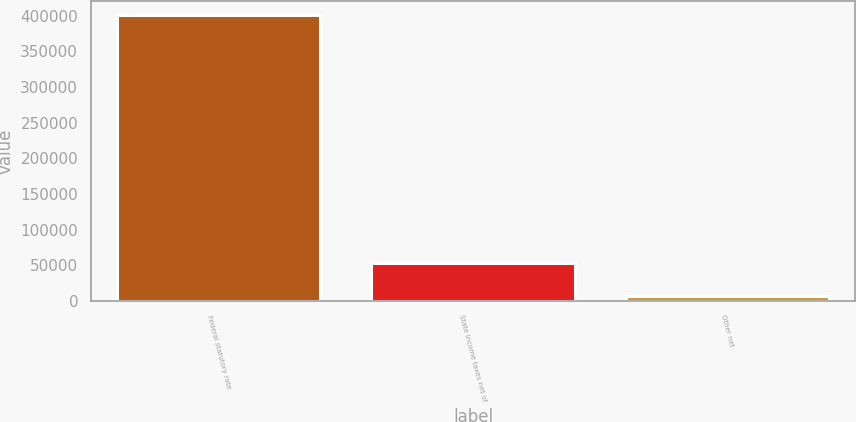Convert chart. <chart><loc_0><loc_0><loc_500><loc_500><bar_chart><fcel>Federal statutory rate<fcel>State income taxes net of<fcel>Other net<nl><fcel>400547<fcel>53501<fcel>7188<nl></chart> 